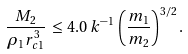<formula> <loc_0><loc_0><loc_500><loc_500>\frac { M _ { 2 } } { \rho _ { 1 } r _ { c 1 } ^ { 3 } } \, \leq \, 4 . 0 \, k ^ { - 1 } \, \left ( \frac { m _ { 1 } } { m _ { 2 } } \right ) ^ { 3 / 2 } .</formula> 